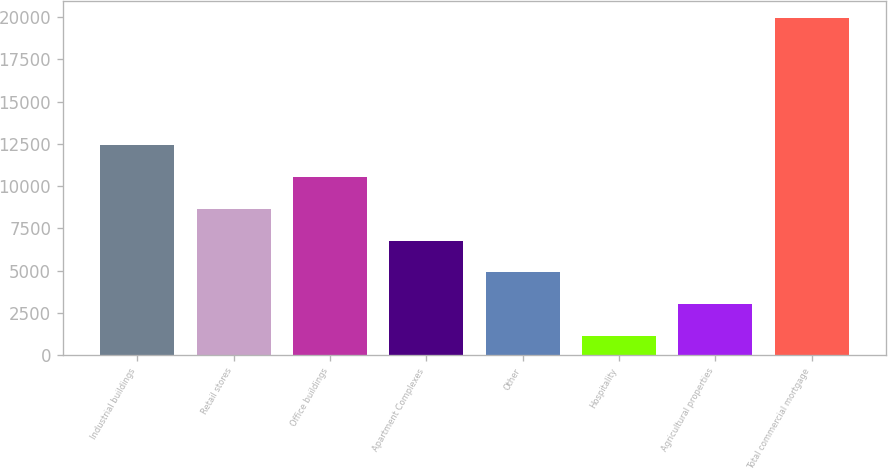<chart> <loc_0><loc_0><loc_500><loc_500><bar_chart><fcel>Industrial buildings<fcel>Retail stores<fcel>Office buildings<fcel>Apartment Complexes<fcel>Other<fcel>Hospitality<fcel>Agricultural properties<fcel>Total commercial mortgage<nl><fcel>12415.2<fcel>8654.8<fcel>10535<fcel>6774.6<fcel>4894.4<fcel>1134<fcel>3014.2<fcel>19936<nl></chart> 